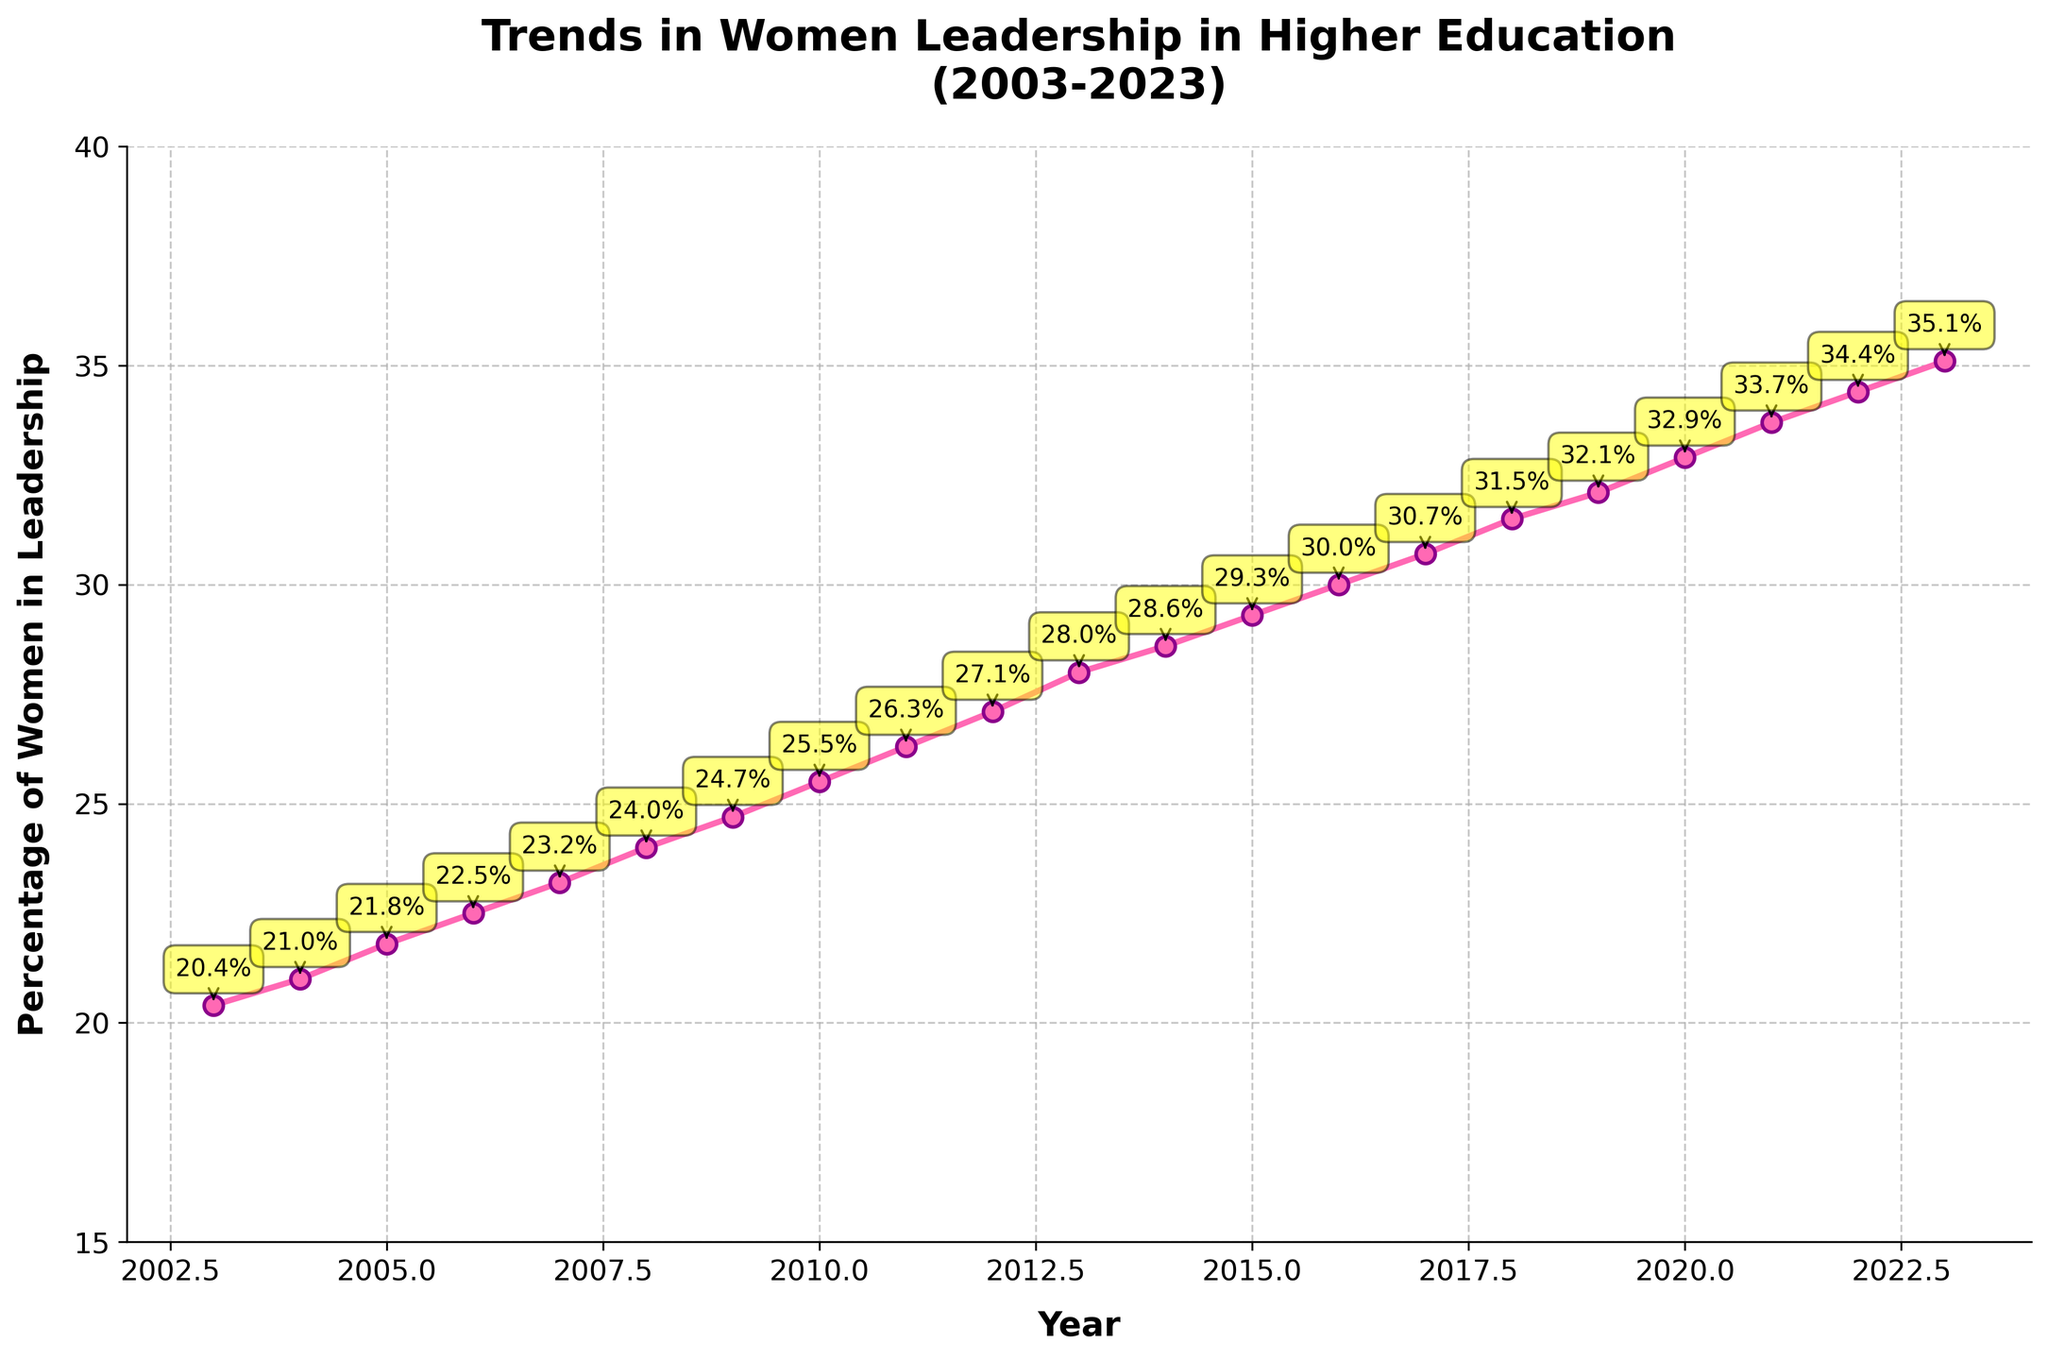What is the title of the figure? The title is displayed at the top of the figure, and it provides an overview of the data. The title reads, "Trends in Women Leadership in Higher Education (2003-2023)."
Answer: Trends in Women Leadership in Higher Education (2003-2023) How many data points are shown in the figure? Each data point corresponds to a year from 2003 to 2023. By counting the years, there are 21 data points represented.
Answer: 21 What was the percentage of women in leadership roles in 2013? Look for the year 2013 on the x-axis, then check the corresponding percentage value on the y-axis next to that year. The figure annotates this value as 28.0%.
Answer: 28.0% Between which years did the percentage of women in leadership roles increase the most? Compare the percentage values year by year and find the largest increment. The largest increase occurred between 2013 (28.0%) and 2014 (28.6%).
Answer: 2013 and 2014 What is the overall trend in the percentage of women in leadership roles? Observe the general direction of the line from left (2003) to right (2023). The line consistently rises, indicating an upward trend in the percentage.
Answer: Upward In what year did the percentage of women in leadership roles first exceed 30%? Trace along the x-axis to find where the y-values first surpass 30%. This happens in the year 2016 when the percentage reaches 30.0%.
Answer: 2016 Calculate the average annual increase in the percentage of women in leadership from 2003 to 2023. Subtract the percentage in 2003 (20.4%) from the percentage in 2023 (35.1%) to get the total change. The change is 14.7%. Divide this by the number of intervals (2023-2003 = 20) to find the average annual increase: 14.7/20 = 0.735%.
Answer: 0.735% Was the percentage of women in leadership roles higher in 2010 or 2020? Compare the annotated values for 2010 (25.5%) and 2020 (32.9%). The percentage in 2020 is higher.
Answer: 2020 What visual elements are used to highlight the data points on the plot? Observe the appearance of the data points. Each point is marked with a pink circle and outlined with a dark purple border. The percentages are annotated with yellow boxes and arrows pointing to the corresponding points.
Answer: Pink circles, dark purple borders, yellow boxes with arrows When was the percentage of women in leadership closest to 25%? Identify the year closest to the 25% mark on the y-axis. This occurs in the year 2010 when the percentage is precisely 25.5%.
Answer: 2010 